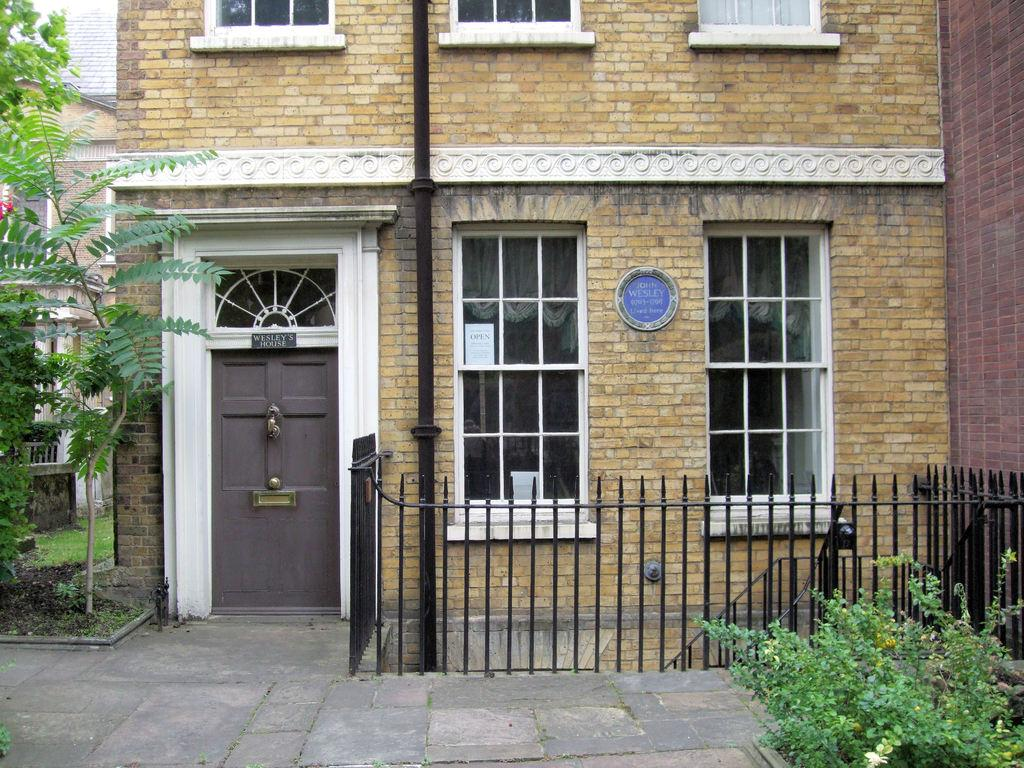What type of structures are present in the image? There are buildings with windows and doors in the image. What is in front of the buildings? There is a fence in front of the building. What can be seen on the ground in the image? The ground is visible in the image. What type of vegetation is present in the image? There are trees and grass in the image. What other object can be seen in the image? There is a pipe in the image. What type of humor is being displayed by the trees in the image? There is no humor being displayed by the trees in the image; they are simply trees. 